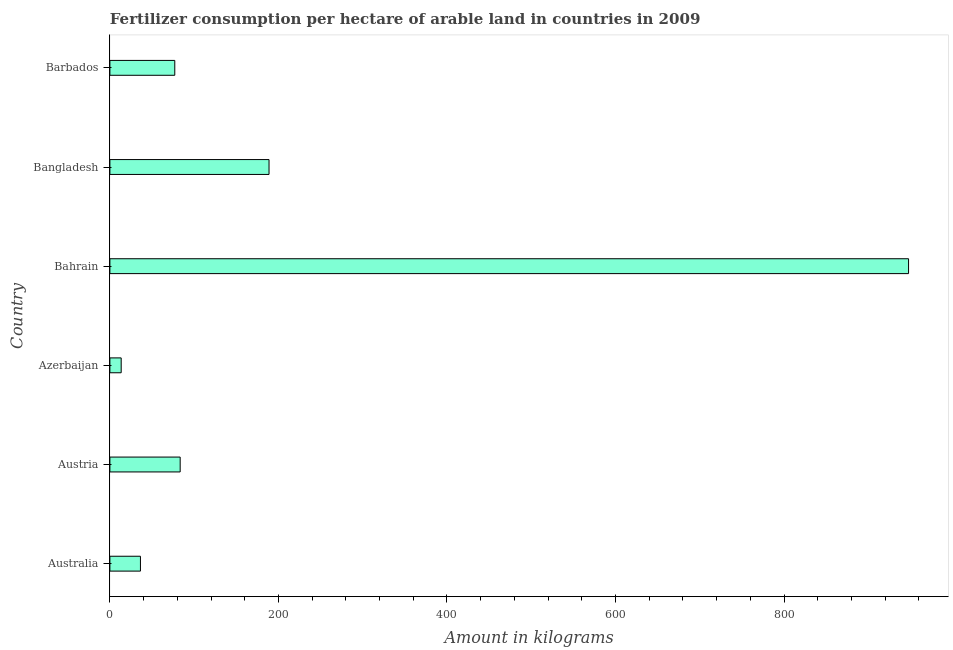Does the graph contain grids?
Provide a short and direct response. No. What is the title of the graph?
Give a very brief answer. Fertilizer consumption per hectare of arable land in countries in 2009 . What is the label or title of the X-axis?
Ensure brevity in your answer.  Amount in kilograms. What is the label or title of the Y-axis?
Your answer should be compact. Country. What is the amount of fertilizer consumption in Azerbaijan?
Make the answer very short. 13.41. Across all countries, what is the maximum amount of fertilizer consumption?
Make the answer very short. 947.79. Across all countries, what is the minimum amount of fertilizer consumption?
Ensure brevity in your answer.  13.41. In which country was the amount of fertilizer consumption maximum?
Provide a short and direct response. Bahrain. In which country was the amount of fertilizer consumption minimum?
Give a very brief answer. Azerbaijan. What is the sum of the amount of fertilizer consumption?
Provide a succinct answer. 1346.72. What is the difference between the amount of fertilizer consumption in Austria and Bangladesh?
Your answer should be very brief. -105.45. What is the average amount of fertilizer consumption per country?
Ensure brevity in your answer.  224.45. What is the median amount of fertilizer consumption?
Give a very brief answer. 80.2. In how many countries, is the amount of fertilizer consumption greater than 800 kg?
Your answer should be compact. 1. What is the ratio of the amount of fertilizer consumption in Australia to that in Barbados?
Give a very brief answer. 0.47. Is the amount of fertilizer consumption in Australia less than that in Azerbaijan?
Offer a very short reply. No. Is the difference between the amount of fertilizer consumption in Bahrain and Bangladesh greater than the difference between any two countries?
Ensure brevity in your answer.  No. What is the difference between the highest and the second highest amount of fertilizer consumption?
Make the answer very short. 758.94. Is the sum of the amount of fertilizer consumption in Azerbaijan and Bahrain greater than the maximum amount of fertilizer consumption across all countries?
Provide a short and direct response. Yes. What is the difference between the highest and the lowest amount of fertilizer consumption?
Offer a terse response. 934.38. How many bars are there?
Keep it short and to the point. 6. How many countries are there in the graph?
Give a very brief answer. 6. What is the Amount in kilograms of Australia?
Your answer should be compact. 36.25. What is the Amount in kilograms in Austria?
Your answer should be very brief. 83.41. What is the Amount in kilograms in Azerbaijan?
Provide a short and direct response. 13.41. What is the Amount in kilograms of Bahrain?
Ensure brevity in your answer.  947.79. What is the Amount in kilograms in Bangladesh?
Provide a succinct answer. 188.85. What is the difference between the Amount in kilograms in Australia and Austria?
Your answer should be very brief. -47.16. What is the difference between the Amount in kilograms in Australia and Azerbaijan?
Your answer should be compact. 22.84. What is the difference between the Amount in kilograms in Australia and Bahrain?
Keep it short and to the point. -911.54. What is the difference between the Amount in kilograms in Australia and Bangladesh?
Your response must be concise. -152.6. What is the difference between the Amount in kilograms in Australia and Barbados?
Provide a short and direct response. -40.75. What is the difference between the Amount in kilograms in Austria and Azerbaijan?
Keep it short and to the point. 69.99. What is the difference between the Amount in kilograms in Austria and Bahrain?
Give a very brief answer. -864.39. What is the difference between the Amount in kilograms in Austria and Bangladesh?
Offer a terse response. -105.45. What is the difference between the Amount in kilograms in Austria and Barbados?
Your answer should be compact. 6.41. What is the difference between the Amount in kilograms in Azerbaijan and Bahrain?
Your answer should be very brief. -934.38. What is the difference between the Amount in kilograms in Azerbaijan and Bangladesh?
Ensure brevity in your answer.  -175.44. What is the difference between the Amount in kilograms in Azerbaijan and Barbados?
Your response must be concise. -63.59. What is the difference between the Amount in kilograms in Bahrain and Bangladesh?
Offer a very short reply. 758.94. What is the difference between the Amount in kilograms in Bahrain and Barbados?
Your response must be concise. 870.79. What is the difference between the Amount in kilograms in Bangladesh and Barbados?
Ensure brevity in your answer.  111.85. What is the ratio of the Amount in kilograms in Australia to that in Austria?
Your answer should be compact. 0.43. What is the ratio of the Amount in kilograms in Australia to that in Azerbaijan?
Offer a terse response. 2.7. What is the ratio of the Amount in kilograms in Australia to that in Bahrain?
Provide a succinct answer. 0.04. What is the ratio of the Amount in kilograms in Australia to that in Bangladesh?
Offer a very short reply. 0.19. What is the ratio of the Amount in kilograms in Australia to that in Barbados?
Provide a short and direct response. 0.47. What is the ratio of the Amount in kilograms in Austria to that in Azerbaijan?
Provide a succinct answer. 6.22. What is the ratio of the Amount in kilograms in Austria to that in Bahrain?
Your response must be concise. 0.09. What is the ratio of the Amount in kilograms in Austria to that in Bangladesh?
Offer a terse response. 0.44. What is the ratio of the Amount in kilograms in Austria to that in Barbados?
Your answer should be very brief. 1.08. What is the ratio of the Amount in kilograms in Azerbaijan to that in Bahrain?
Your answer should be compact. 0.01. What is the ratio of the Amount in kilograms in Azerbaijan to that in Bangladesh?
Your answer should be very brief. 0.07. What is the ratio of the Amount in kilograms in Azerbaijan to that in Barbados?
Make the answer very short. 0.17. What is the ratio of the Amount in kilograms in Bahrain to that in Bangladesh?
Ensure brevity in your answer.  5.02. What is the ratio of the Amount in kilograms in Bahrain to that in Barbados?
Provide a short and direct response. 12.31. What is the ratio of the Amount in kilograms in Bangladesh to that in Barbados?
Provide a succinct answer. 2.45. 